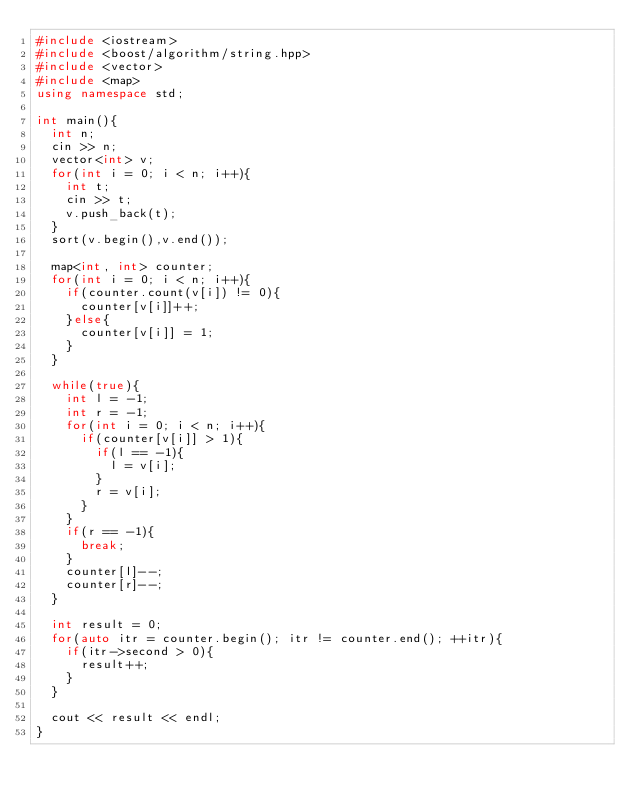Convert code to text. <code><loc_0><loc_0><loc_500><loc_500><_C++_>#include <iostream>
#include <boost/algorithm/string.hpp>
#include <vector>
#include <map>
using namespace std;

int main(){
  int n;
  cin >> n;
  vector<int> v;
  for(int i = 0; i < n; i++){
    int t;
    cin >> t;
    v.push_back(t);
  }
  sort(v.begin(),v.end());

  map<int, int> counter;
  for(int i = 0; i < n; i++){
    if(counter.count(v[i]) != 0){
      counter[v[i]]++;
    }else{
      counter[v[i]] = 1;
    }
  }

  while(true){
    int l = -1;
    int r = -1;
    for(int i = 0; i < n; i++){
      if(counter[v[i]] > 1){
        if(l == -1){
          l = v[i];
        }
        r = v[i];
      }
    }
    if(r == -1){
      break;
    }
    counter[l]--;
    counter[r]--;
  }

  int result = 0;
  for(auto itr = counter.begin(); itr != counter.end(); ++itr){
    if(itr->second > 0){
      result++;
    }
  }

  cout << result << endl;
}
</code> 